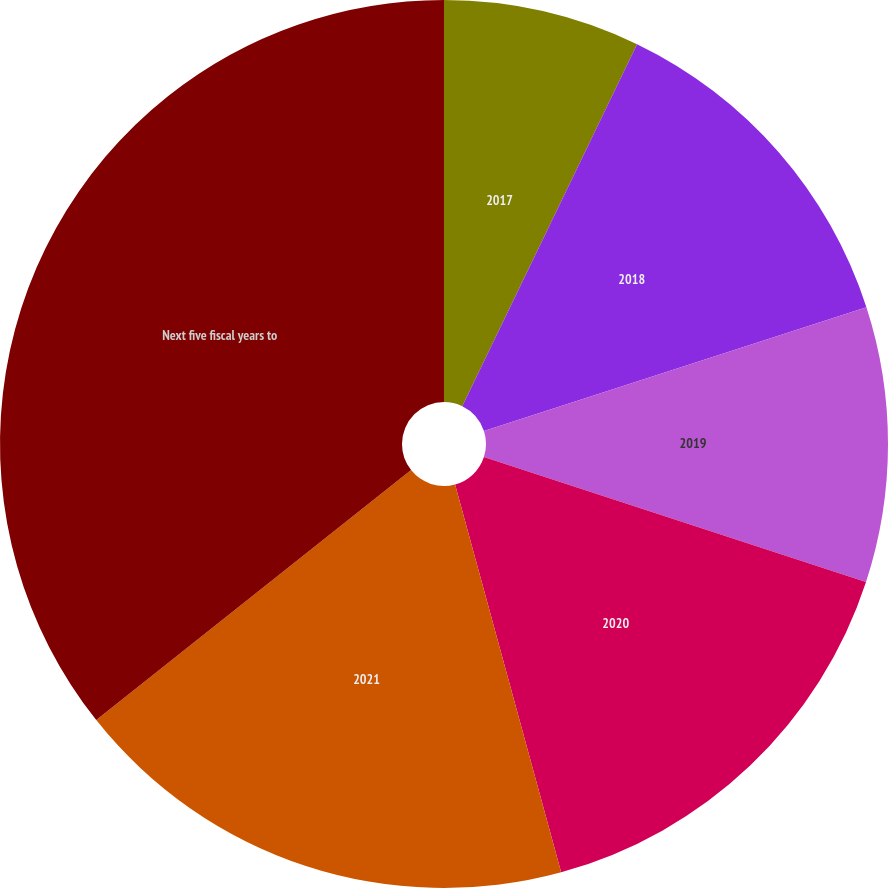Convert chart. <chart><loc_0><loc_0><loc_500><loc_500><pie_chart><fcel>2017<fcel>2018<fcel>2019<fcel>2020<fcel>2021<fcel>Next five fiscal years to<nl><fcel>7.16%<fcel>12.86%<fcel>10.01%<fcel>15.72%<fcel>18.57%<fcel>35.68%<nl></chart> 